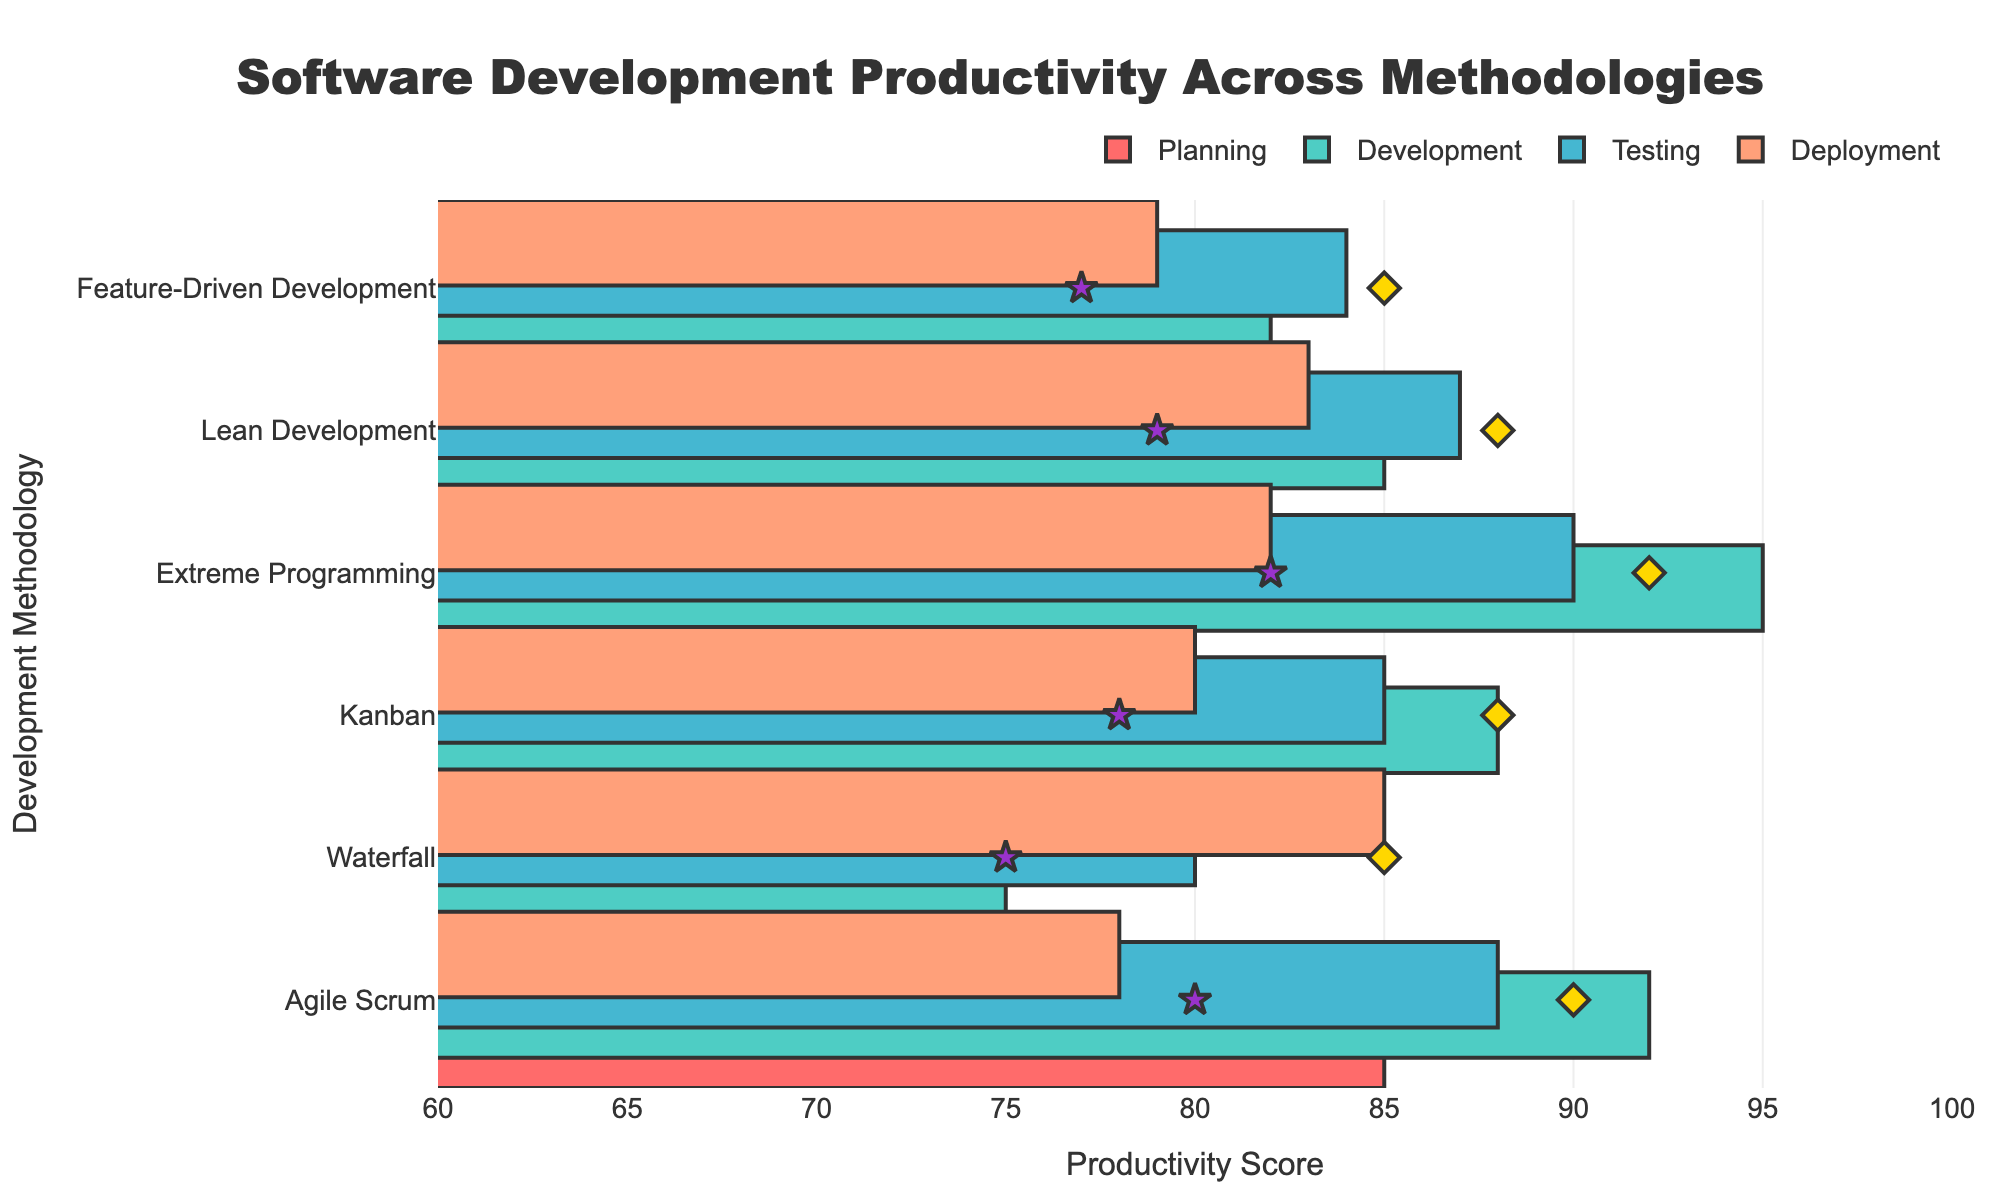What is the average productivity score for development across all methodologies? To find the average productivity score for development, add the productivity scores for each methodology and divide by the number of methodologies: (92 + 75 + 88 + 95 + 85 + 82) / 6. This gives (517) / 6 = 86.17
Answer: 86.17 Which methodology has the highest productivity score during testing? Look at the testing productivity scores for each methodology and identify the highest one. The scores are Agile Scrum (88), Waterfall (80), Kanban (85), Extreme Programming (90), Lean Development (87), and Feature-Driven Development (84). The highest score is 90 for Extreme Programming.
Answer: Extreme Programming How many methodologies exceed the target productivity score in the deployment stage? Compare the deployment productivity scores with the target score (82): Agile Scrum (78 < 90), Waterfall (85 = 85), Kanban (80 < 88), Extreme Programming (82 < 92), Lean Development (83 < 88), and Feature-Driven Development (79 < 85). Only Waterfall exceeds its target in deployment.
Answer: 1 Which stage has the lowest average productivity score across all methodologies? Calculate the average score for each stage: 
Planning (85 + 70 + 82 + 78 + 80 + 75)/6 = 78.33,
Development (92 + 75 + 88 + 95 + 85 + 82)/6 = 86.17,
Testing (88 + 80 + 85 + 90 + 87 + 84)/6 = 85.67,
Deployment (78 + 85 + 80 + 82 + 83 + 79)/6 = 81.17.
The lowest average is for Planning.
Answer: Planning What is the total productivity score for Lean Development in all stages combined? Add all the productivity scores for Lean Development: 80 + 85 + 87 + 83. This gives a total of 335.
Answer: 335 